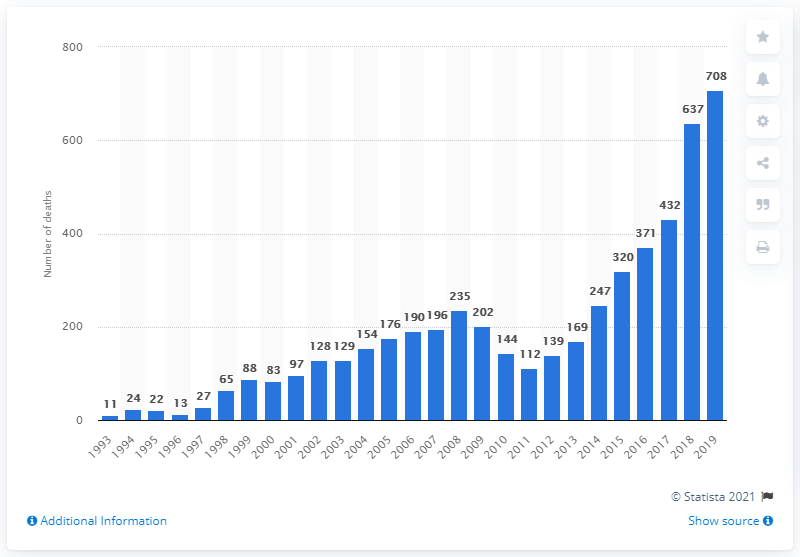Indicate a few pertinent items in this graphic. By 2019, the number of deaths due to cocaine use had risen to 708. 